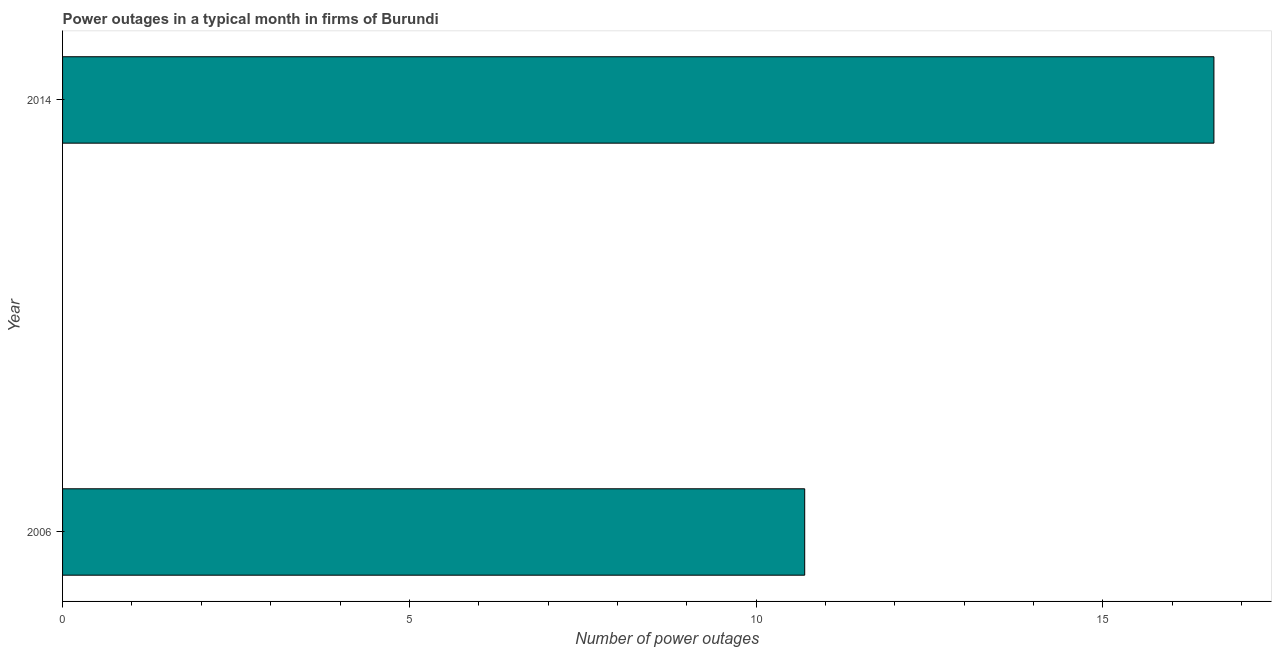Does the graph contain any zero values?
Provide a short and direct response. No. What is the title of the graph?
Your answer should be compact. Power outages in a typical month in firms of Burundi. What is the label or title of the X-axis?
Offer a terse response. Number of power outages. What is the label or title of the Y-axis?
Keep it short and to the point. Year. Across all years, what is the maximum number of power outages?
Offer a terse response. 16.6. In which year was the number of power outages maximum?
Offer a very short reply. 2014. In which year was the number of power outages minimum?
Your response must be concise. 2006. What is the sum of the number of power outages?
Your answer should be very brief. 27.3. What is the average number of power outages per year?
Offer a very short reply. 13.65. What is the median number of power outages?
Offer a very short reply. 13.65. Do a majority of the years between 2014 and 2006 (inclusive) have number of power outages greater than 11 ?
Offer a terse response. No. What is the ratio of the number of power outages in 2006 to that in 2014?
Give a very brief answer. 0.65. Is the number of power outages in 2006 less than that in 2014?
Your response must be concise. Yes. How many bars are there?
Provide a short and direct response. 2. How many years are there in the graph?
Provide a succinct answer. 2. Are the values on the major ticks of X-axis written in scientific E-notation?
Your answer should be very brief. No. What is the difference between the Number of power outages in 2006 and 2014?
Your response must be concise. -5.9. What is the ratio of the Number of power outages in 2006 to that in 2014?
Provide a short and direct response. 0.65. 